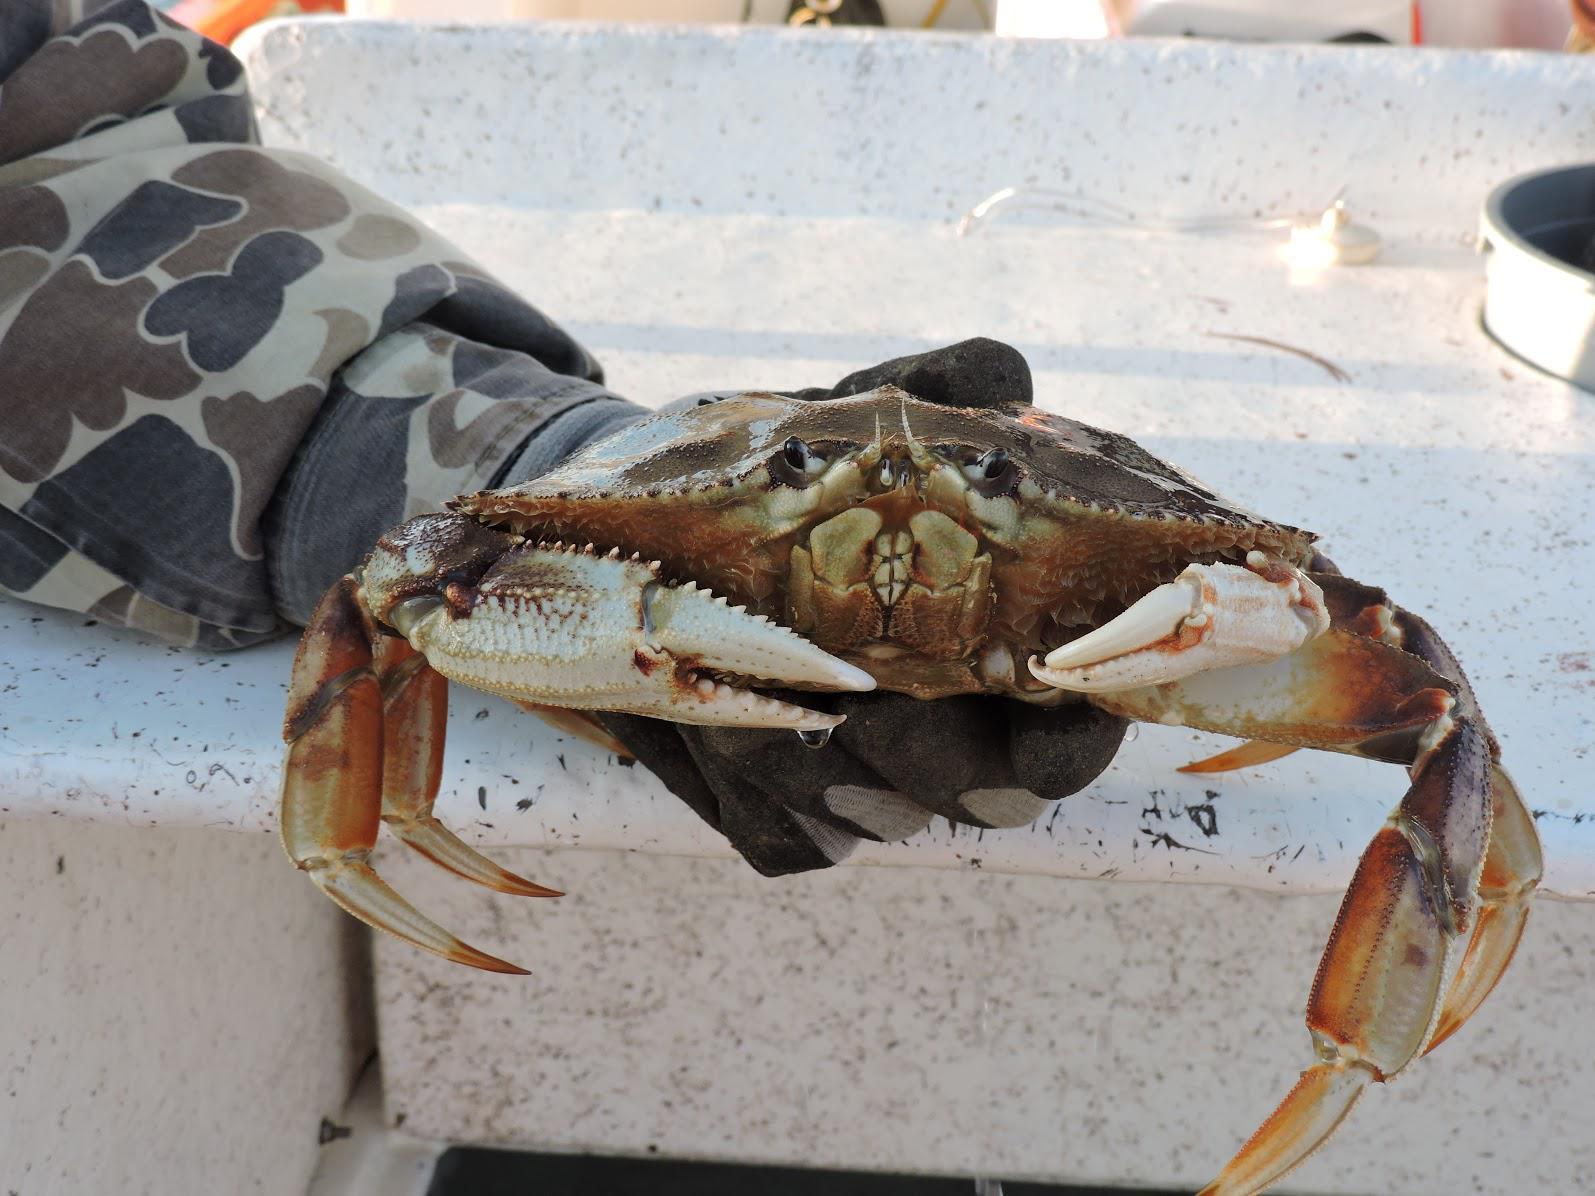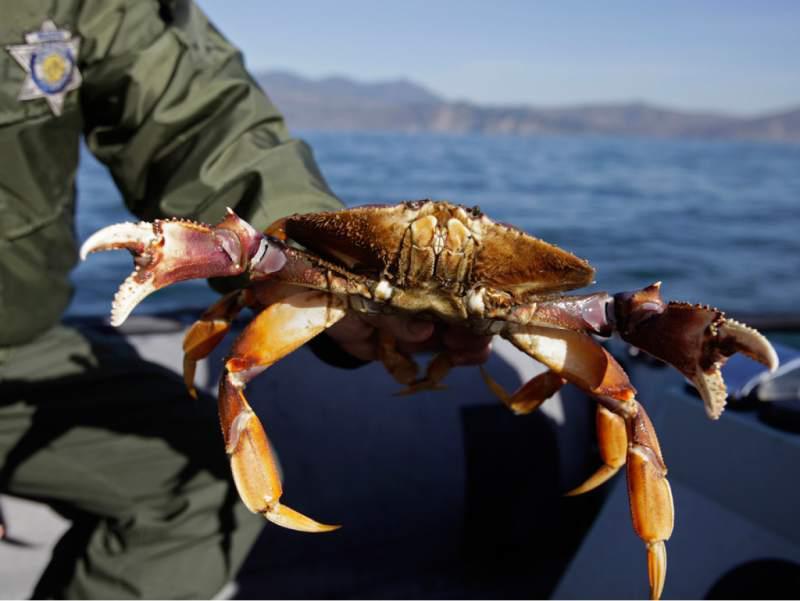The first image is the image on the left, the second image is the image on the right. Assess this claim about the two images: "Each image includes a hand near one crab, and one image shows a bare hand grasping a crab and holding it up in front of a body of water.". Correct or not? Answer yes or no. Yes. The first image is the image on the left, the second image is the image on the right. Examine the images to the left and right. Is the description "A person is holding a crab in the image on the left." accurate? Answer yes or no. Yes. 